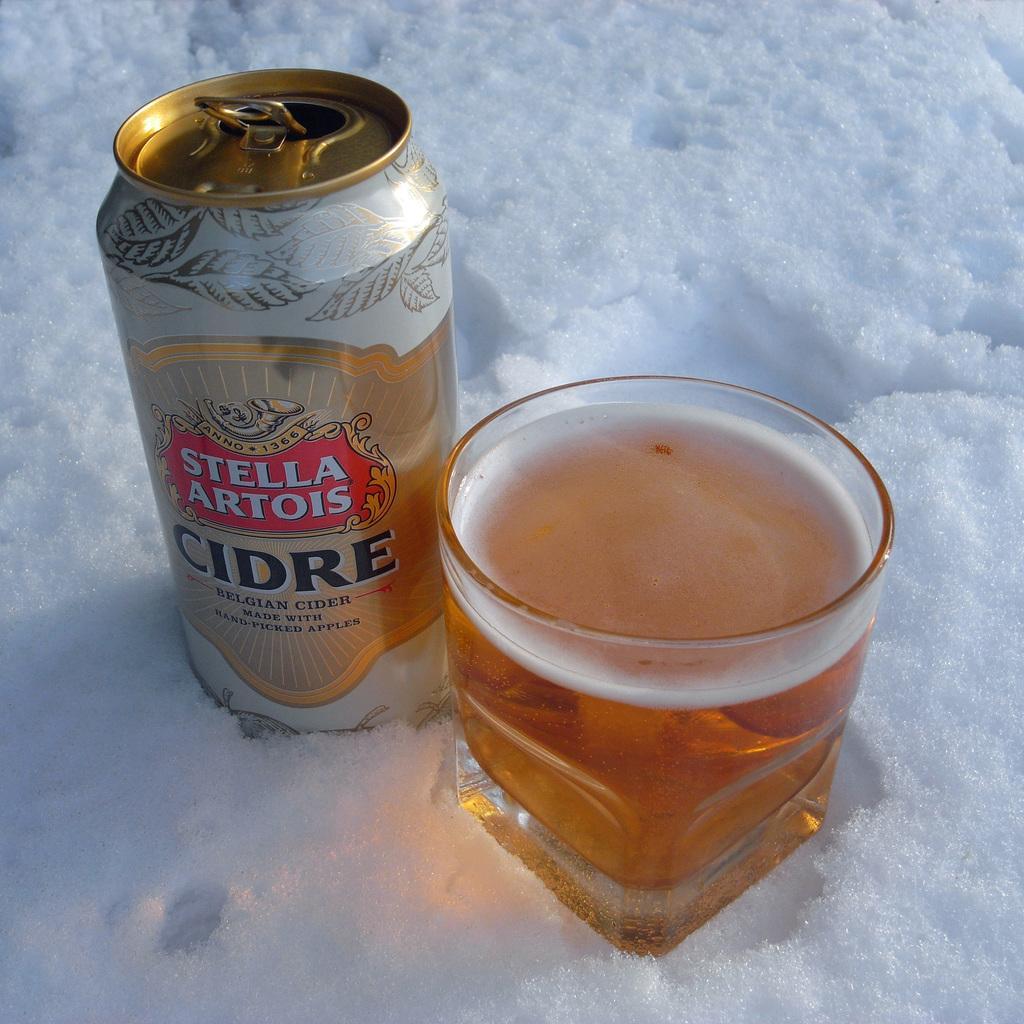Describe this image in one or two sentences. In this image I can see snow, a can, a glass and in it I can see liquid. On this can I can see something is written. 